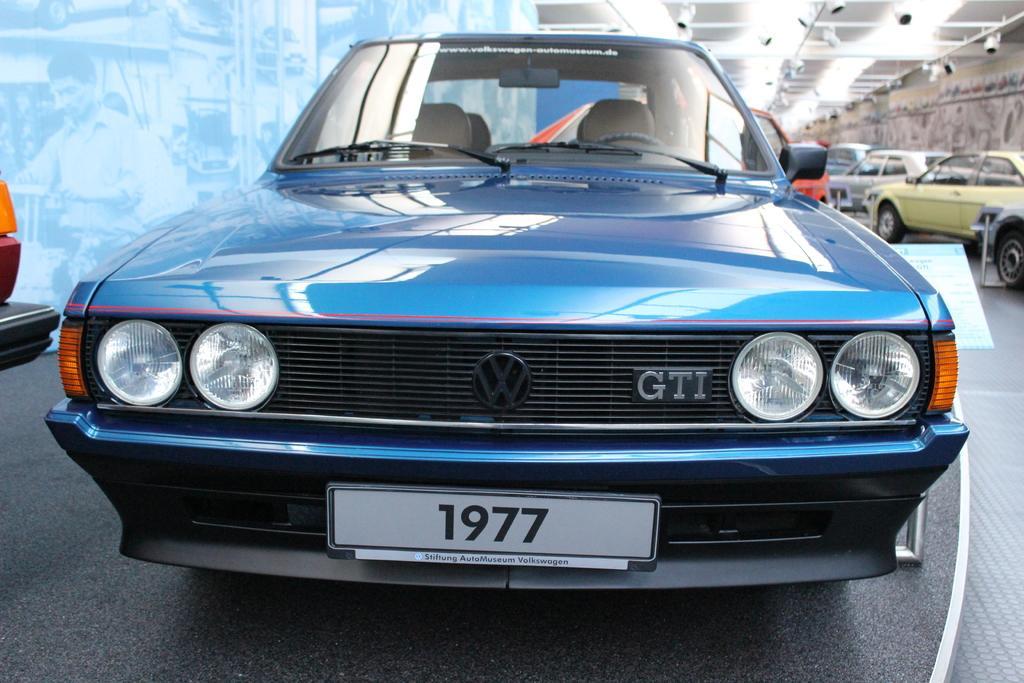Please provide a concise description of this image. In this picture we can see cars on the floor, screen, wall, lights and on this screen we can see two people and some objects. 